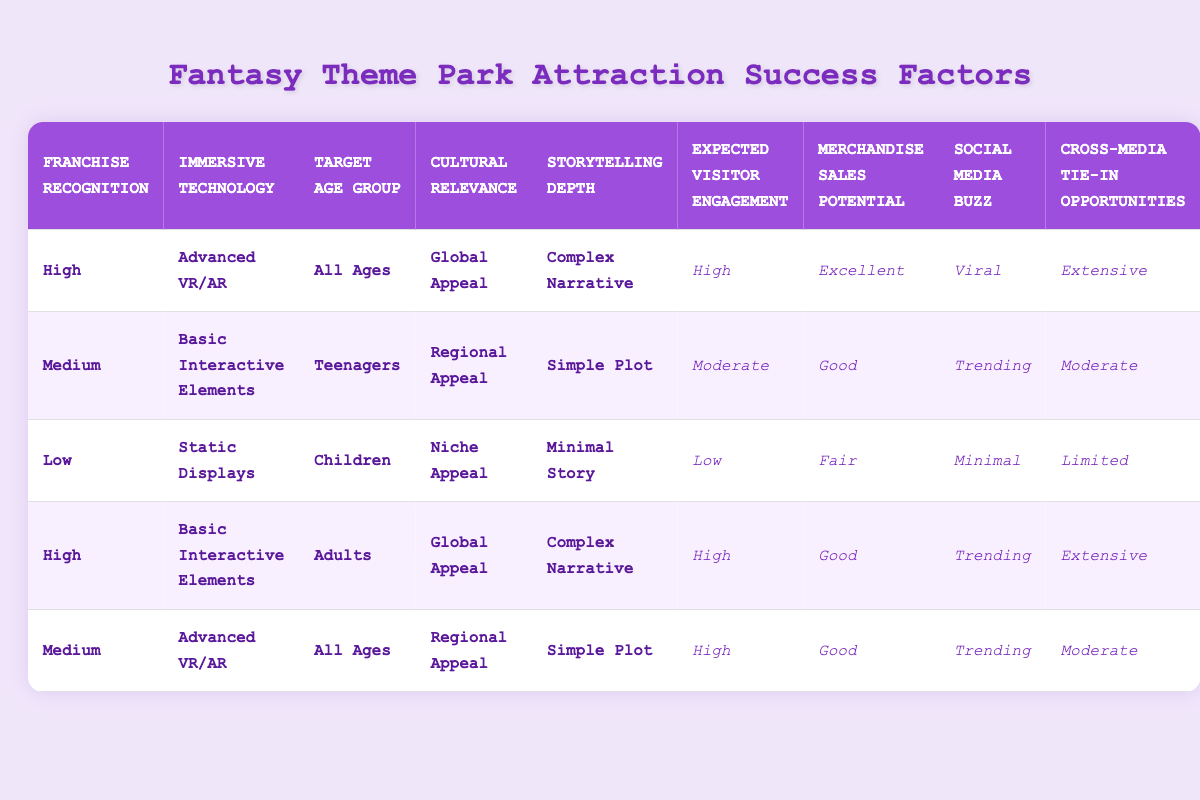What is the expected visitor engagement for attractions with high franchise recognition and advanced VR/AR technology? Referring to the table, under the conditions of "High" for Franchise Recognition and "Advanced VR/AR" for Immersive Technology, the corresponding expected visitor engagement is "High."
Answer: High Which target age group has the highest merchandise sales potential according to the table? The table indicates that both "All Ages" with "High" franchise recognition and "Advanced VR/AR" technology and "Adults" with "High" franchise recognition and "Basic Interactive Elements" have "Excellent" merchandise sales potential. Thus, the highest potential applies to the "All Ages" group under those conditions.
Answer: All Ages Is cultural relevance of "Niche Appeal" associated with high expected visitor engagement? Looking at the conditions, "Niche Appeal" is linked to a low expected visitor engagement of "Low" when combined with "Low" franchise recognition, "Static Displays", "Children" target age group, and "Minimal Story." Therefore, the statement is false.
Answer: No What actions result from a medium recognition franchise with basic interactive elements and targeting teenagers? The table states that under these conditions (Medium franchise recognition, Basic Interactive Elements, Teenagers, Regional Appeal, and Simple Plot), the actions result in "Moderate" expected visitor engagement, "Good" merchandise sales potential, "Trending" social media buzz, and "Moderate" cross-media tie-in opportunities.
Answer: Moderate engagement, Good sales, Trending buzz, Moderate tie-in If we add up the expected visitor engagement levels from all the scenarios, how many are classified as high? According to the table, there are two scenarios classified as "High" expected visitor engagement. The first is for "High" Franchise Recognition, "Advanced VR/AR," "All Ages," "Global Appeal," "Complex Narrative," and the second is for "High" Franchise Recognition with "Basic Interactive Elements," targeting "Adults" and having "Complex Narrative." Therefore, the total is 2.
Answer: 2 